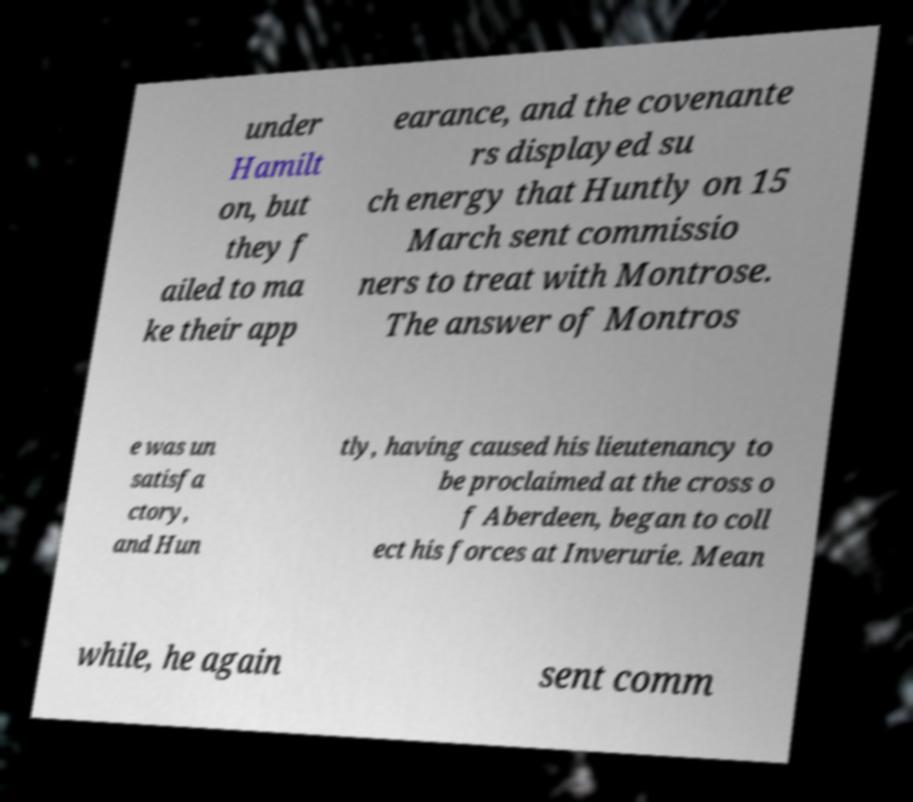For documentation purposes, I need the text within this image transcribed. Could you provide that? under Hamilt on, but they f ailed to ma ke their app earance, and the covenante rs displayed su ch energy that Huntly on 15 March sent commissio ners to treat with Montrose. The answer of Montros e was un satisfa ctory, and Hun tly, having caused his lieutenancy to be proclaimed at the cross o f Aberdeen, began to coll ect his forces at Inverurie. Mean while, he again sent comm 